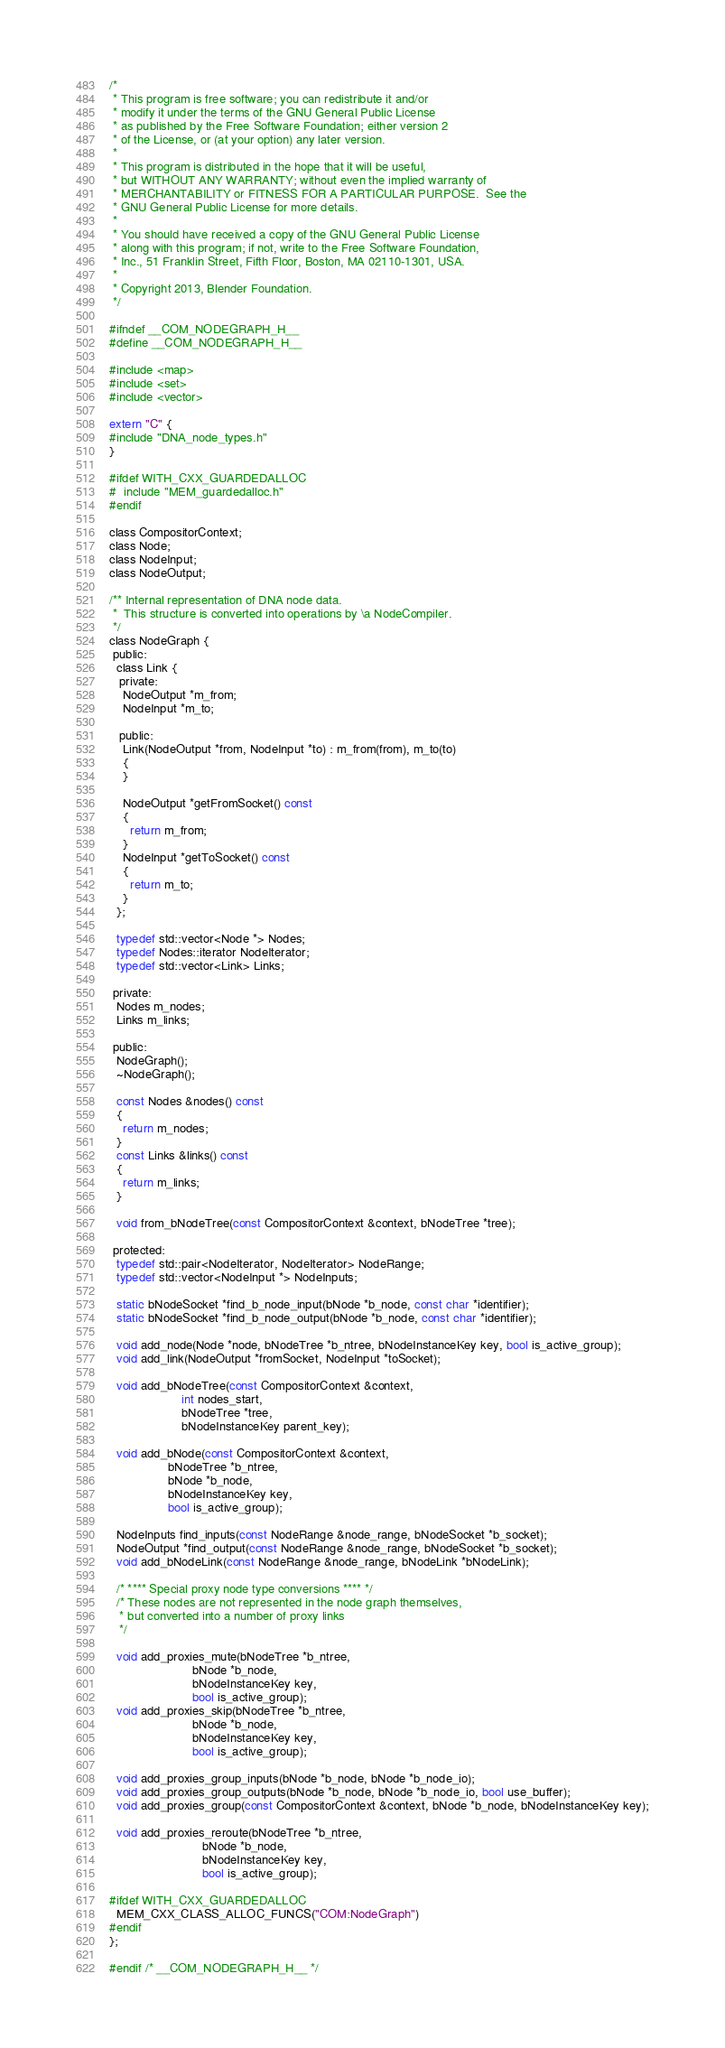<code> <loc_0><loc_0><loc_500><loc_500><_C_>/*
 * This program is free software; you can redistribute it and/or
 * modify it under the terms of the GNU General Public License
 * as published by the Free Software Foundation; either version 2
 * of the License, or (at your option) any later version.
 *
 * This program is distributed in the hope that it will be useful,
 * but WITHOUT ANY WARRANTY; without even the implied warranty of
 * MERCHANTABILITY or FITNESS FOR A PARTICULAR PURPOSE.  See the
 * GNU General Public License for more details.
 *
 * You should have received a copy of the GNU General Public License
 * along with this program; if not, write to the Free Software Foundation,
 * Inc., 51 Franklin Street, Fifth Floor, Boston, MA 02110-1301, USA.
 *
 * Copyright 2013, Blender Foundation.
 */

#ifndef __COM_NODEGRAPH_H__
#define __COM_NODEGRAPH_H__

#include <map>
#include <set>
#include <vector>

extern "C" {
#include "DNA_node_types.h"
}

#ifdef WITH_CXX_GUARDEDALLOC
#  include "MEM_guardedalloc.h"
#endif

class CompositorContext;
class Node;
class NodeInput;
class NodeOutput;

/** Internal representation of DNA node data.
 *  This structure is converted into operations by \a NodeCompiler.
 */
class NodeGraph {
 public:
  class Link {
   private:
    NodeOutput *m_from;
    NodeInput *m_to;

   public:
    Link(NodeOutput *from, NodeInput *to) : m_from(from), m_to(to)
    {
    }

    NodeOutput *getFromSocket() const
    {
      return m_from;
    }
    NodeInput *getToSocket() const
    {
      return m_to;
    }
  };

  typedef std::vector<Node *> Nodes;
  typedef Nodes::iterator NodeIterator;
  typedef std::vector<Link> Links;

 private:
  Nodes m_nodes;
  Links m_links;

 public:
  NodeGraph();
  ~NodeGraph();

  const Nodes &nodes() const
  {
    return m_nodes;
  }
  const Links &links() const
  {
    return m_links;
  }

  void from_bNodeTree(const CompositorContext &context, bNodeTree *tree);

 protected:
  typedef std::pair<NodeIterator, NodeIterator> NodeRange;
  typedef std::vector<NodeInput *> NodeInputs;

  static bNodeSocket *find_b_node_input(bNode *b_node, const char *identifier);
  static bNodeSocket *find_b_node_output(bNode *b_node, const char *identifier);

  void add_node(Node *node, bNodeTree *b_ntree, bNodeInstanceKey key, bool is_active_group);
  void add_link(NodeOutput *fromSocket, NodeInput *toSocket);

  void add_bNodeTree(const CompositorContext &context,
                     int nodes_start,
                     bNodeTree *tree,
                     bNodeInstanceKey parent_key);

  void add_bNode(const CompositorContext &context,
                 bNodeTree *b_ntree,
                 bNode *b_node,
                 bNodeInstanceKey key,
                 bool is_active_group);

  NodeInputs find_inputs(const NodeRange &node_range, bNodeSocket *b_socket);
  NodeOutput *find_output(const NodeRange &node_range, bNodeSocket *b_socket);
  void add_bNodeLink(const NodeRange &node_range, bNodeLink *bNodeLink);

  /* **** Special proxy node type conversions **** */
  /* These nodes are not represented in the node graph themselves,
   * but converted into a number of proxy links
   */

  void add_proxies_mute(bNodeTree *b_ntree,
                        bNode *b_node,
                        bNodeInstanceKey key,
                        bool is_active_group);
  void add_proxies_skip(bNodeTree *b_ntree,
                        bNode *b_node,
                        bNodeInstanceKey key,
                        bool is_active_group);

  void add_proxies_group_inputs(bNode *b_node, bNode *b_node_io);
  void add_proxies_group_outputs(bNode *b_node, bNode *b_node_io, bool use_buffer);
  void add_proxies_group(const CompositorContext &context, bNode *b_node, bNodeInstanceKey key);

  void add_proxies_reroute(bNodeTree *b_ntree,
                           bNode *b_node,
                           bNodeInstanceKey key,
                           bool is_active_group);

#ifdef WITH_CXX_GUARDEDALLOC
  MEM_CXX_CLASS_ALLOC_FUNCS("COM:NodeGraph")
#endif
};

#endif /* __COM_NODEGRAPH_H__ */
</code> 